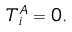Convert formula to latex. <formula><loc_0><loc_0><loc_500><loc_500>T _ { i } ^ { A } = 0 .</formula> 